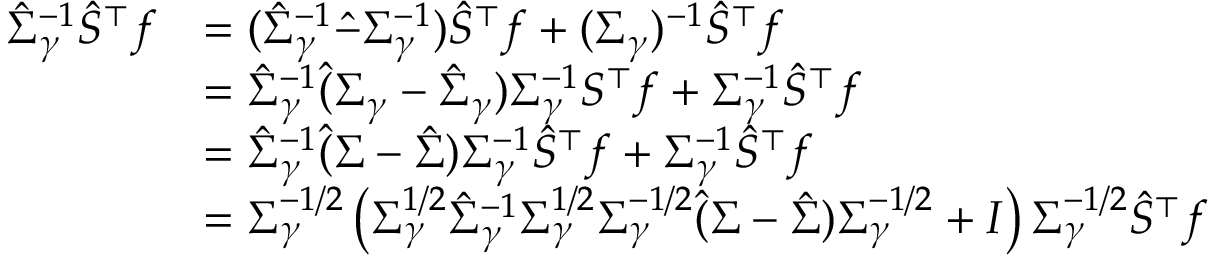<formula> <loc_0><loc_0><loc_500><loc_500>\begin{array} { r l } { \hat { \Sigma } _ { \gamma } ^ { - 1 } \hat { S } ^ { \top } f } & { = ( \hat { \Sigma } _ { \gamma } ^ { - 1 } \hat { - } \Sigma _ { \gamma } ^ { - 1 } ) \hat { S } ^ { \top } f + ( \Sigma _ { \gamma } ) ^ { - 1 } \hat { S } ^ { \top } f } \\ & { = \hat { \Sigma } _ { \gamma } ^ { - 1 } \hat { ( } \Sigma _ { \gamma } - \hat { \Sigma } _ { \gamma } ) \Sigma _ { \gamma } ^ { - 1 } S ^ { \top } f + \Sigma _ { \gamma } ^ { - 1 } \hat { S } ^ { \top } f } \\ & { = \hat { \Sigma } _ { \gamma } ^ { - 1 } \hat { ( } \Sigma - \hat { \Sigma } ) \Sigma _ { \gamma } ^ { - 1 } \hat { S } ^ { \top } f + \Sigma _ { \gamma } ^ { - 1 } \hat { S } ^ { \top } f } \\ & { = \Sigma _ { \gamma } ^ { - 1 / 2 } \left ( \Sigma _ { \gamma } ^ { 1 / 2 } \hat { \Sigma } _ { \gamma } ^ { - 1 } \Sigma _ { \gamma } ^ { 1 / 2 } \Sigma _ { \gamma } ^ { - 1 / 2 } \hat { ( } \Sigma - \hat { \Sigma } ) \Sigma _ { \gamma } ^ { - 1 / 2 } + I \right ) \Sigma _ { \gamma } ^ { - 1 / 2 } \hat { S } ^ { \top } f } \end{array}</formula> 